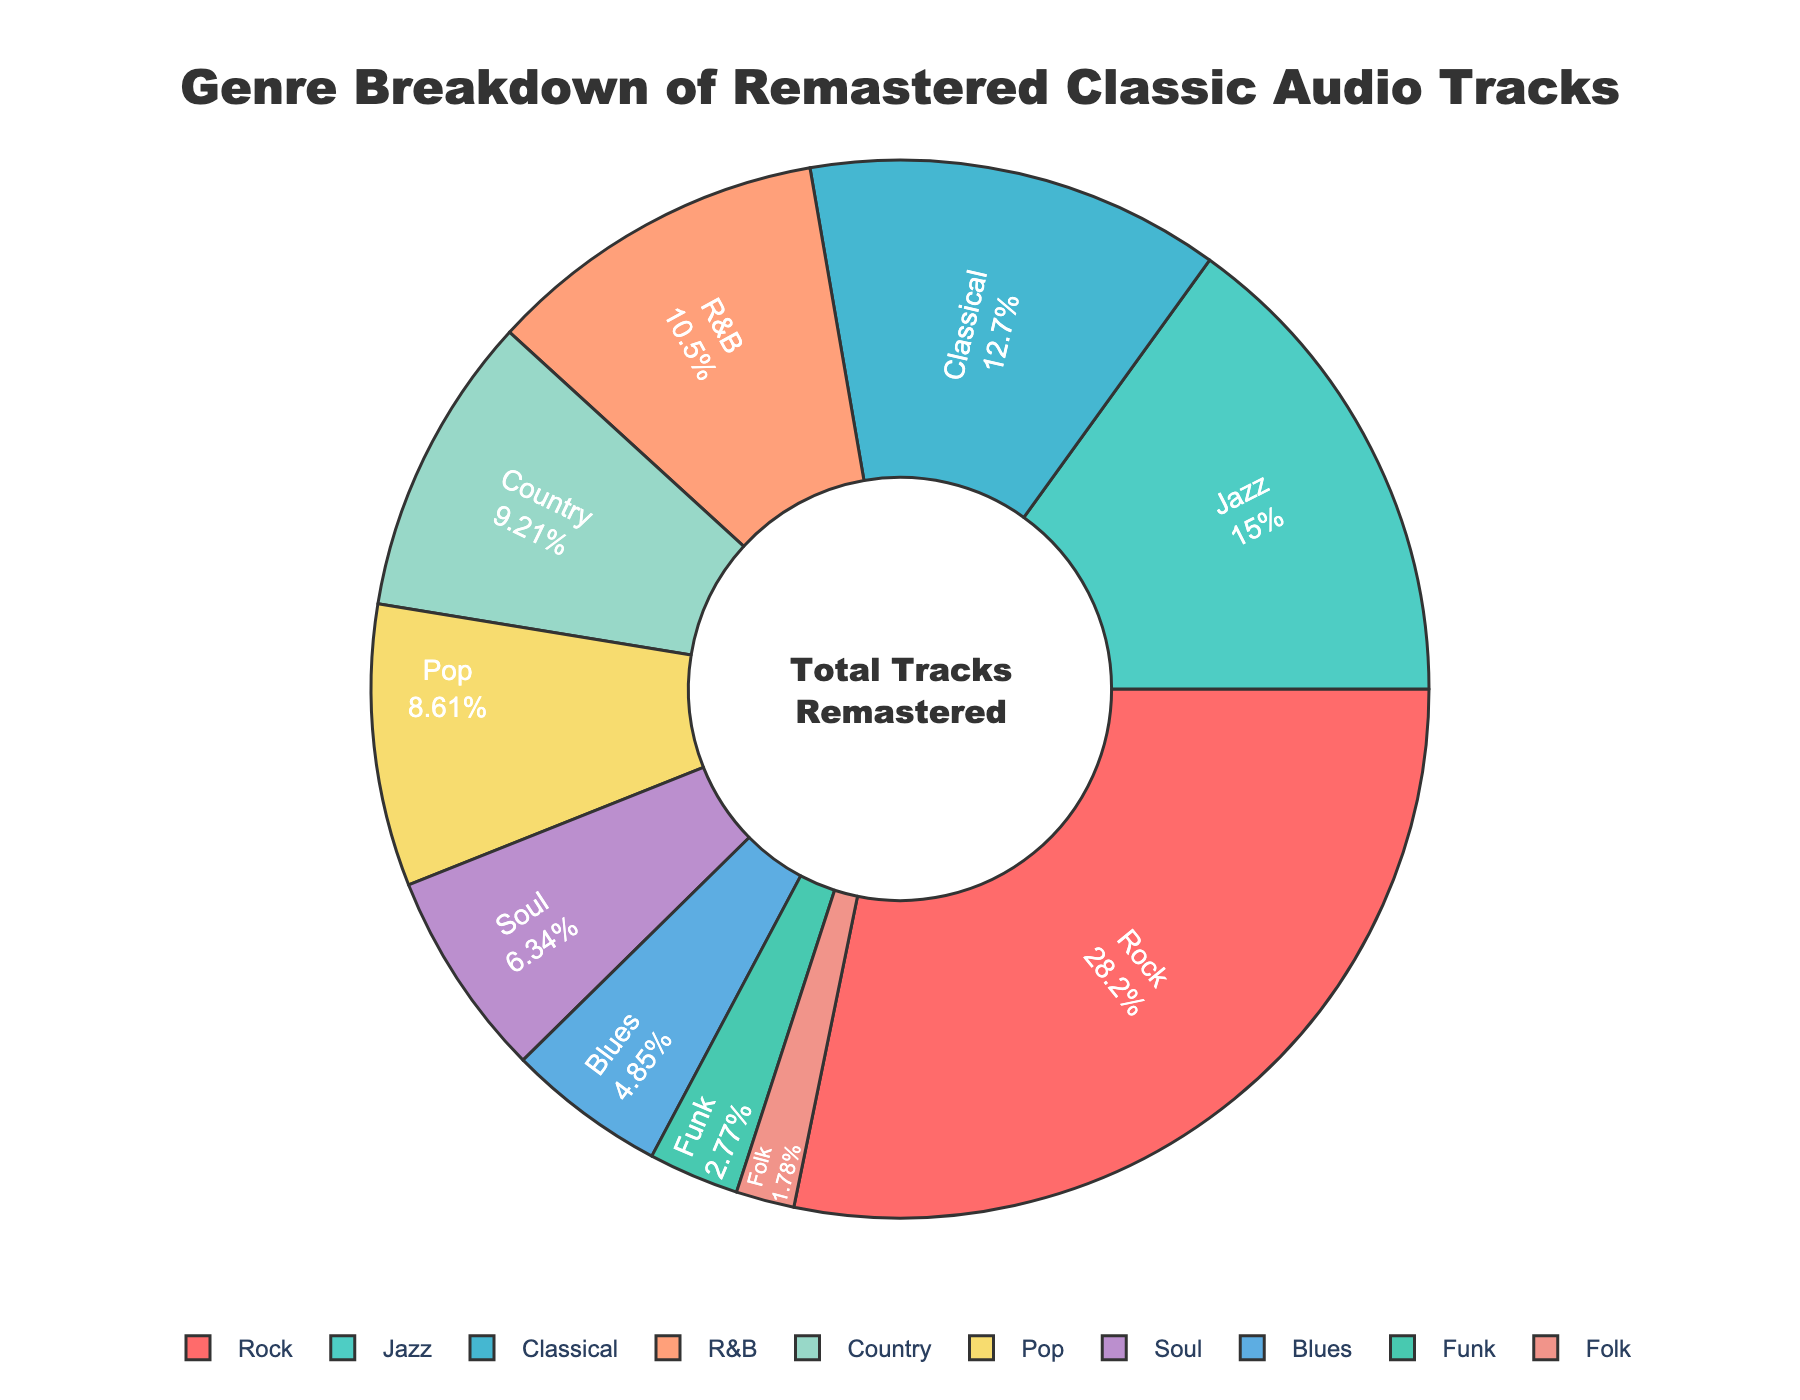Which genre has the highest percentage in the chart? By visually inspecting the pie chart, the section labeled "Rock" appears the largest. Its displayed percentage is 28.5%, indicating it has the highest percentage.
Answer: Rock What is the combined percentage of Jazz and Classical music? To find the combined percentage, sum the percentages of Jazz (15.2%) and Classical (12.8%). So, 15.2 + 12.8 = 28.0%.
Answer: 28.0% Compare the percentage of Pop and Soul music. Which one is higher? By looking at the pie chart, the section for Pop is labeled with 8.7%, while the section for Soul is labeled with 6.4%. Clearly, 8.7% (Pop) is higher than 6.4% (Soul).
Answer: Pop How much larger is the percentage of Rock compared to Folk music? Subtract the percentage of Folk (1.8%) from the percentage of Rock (28.5%). So, 28.5 - 1.8 = 26.7%.
Answer: 26.7% What fraction of the remastered tracks are in genres other than Rock, Jazz, and Classical? First, find the total percentage of Rock, Jazz, and Classical: 28.5 + 15.2 + 12.8 = 56.5%. Then subtract this from 100% to find the remaining fraction: 100 - 56.5 = 43.5%.
Answer: 43.5% Which genre has the smallest percentage, and what is it? By inspecting the smallest section of the pie chart, the genre "Folk" appears to be the smallest. Its displayed percentage is 1.8%.
Answer: Folk Is the percentage of R&B higher than the combined percentage of Funk and Folk? First, find the combined percentage of Funk (2.8%) and Folk (1.8%): 2.8 + 1.8 = 4.6%. Then, compare this to R&B's percentage (10.6%). Since 10.6% is greater than 4.6%, R&B's percentage is indeed higher.
Answer: Yes What proportion of the chart is made up of R&B, Country, and Pop combined? Sum the percentages of R&B (10.6%), Country (9.3%), and Pop (8.7%): 10.6 + 9.3 + 8.7 = 28.6%.
Answer: 28.6% Count the number of genres that have a percentage less than 10%. By going through the chart: Classical (12.8%) is more than 10%, Jazz (15.2%) is more than 10%, Rock (28.5%) is more than 10%, while Pop (8.7%), Soul (6.4%), Blues (4.9%), Funk (2.8%), and Folk (1.8%) all have percentages less than 10%. In total, this makes 5 genres with less than 10%.
Answer: 5 